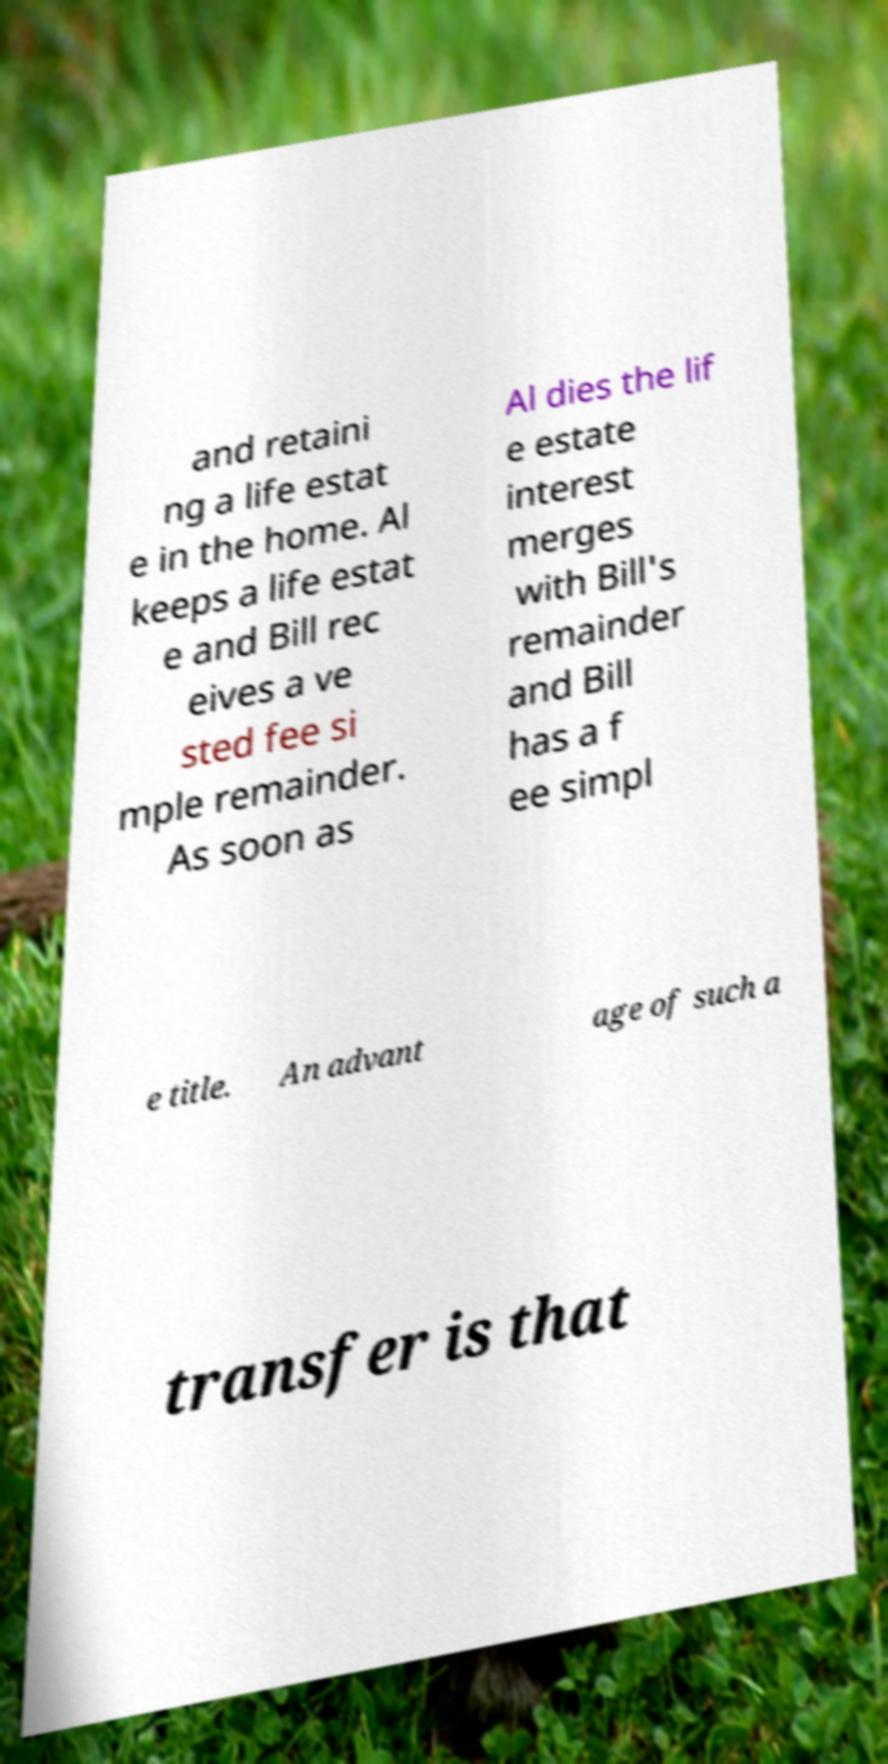Can you read and provide the text displayed in the image?This photo seems to have some interesting text. Can you extract and type it out for me? and retaini ng a life estat e in the home. Al keeps a life estat e and Bill rec eives a ve sted fee si mple remainder. As soon as Al dies the lif e estate interest merges with Bill's remainder and Bill has a f ee simpl e title. An advant age of such a transfer is that 